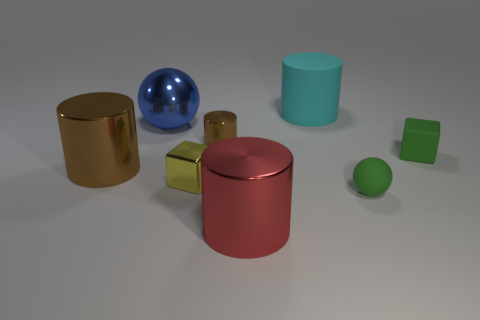How many brown cylinders must be subtracted to get 1 brown cylinders? 1 Add 2 big balls. How many objects exist? 10 Subtract all spheres. How many objects are left? 6 Add 1 large blue shiny spheres. How many large blue shiny spheres exist? 2 Subtract 1 yellow cubes. How many objects are left? 7 Subtract all large red shiny cylinders. Subtract all large yellow things. How many objects are left? 7 Add 6 small green matte cubes. How many small green matte cubes are left? 7 